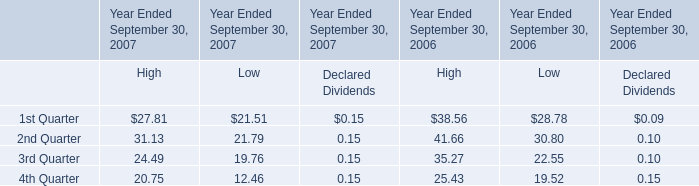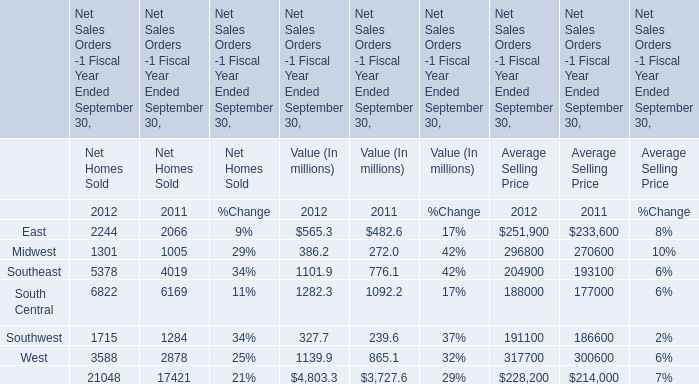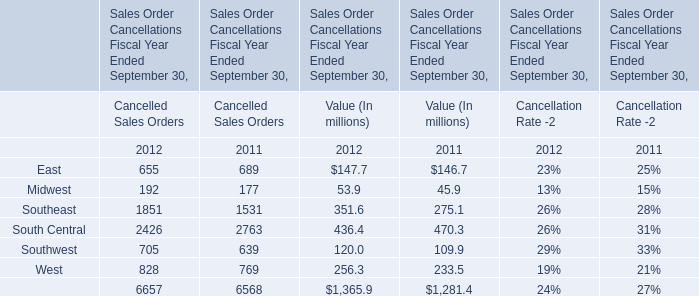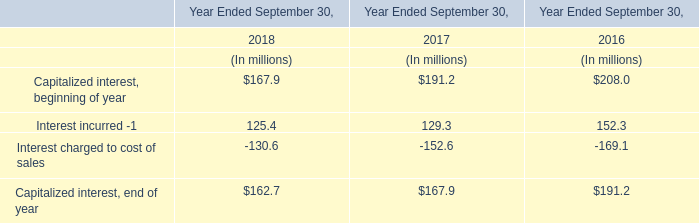In the year with the greatest proportion of East, what is the proportion of East to the tatal? 
Computations: (689 / 6568)
Answer: 0.1049. 